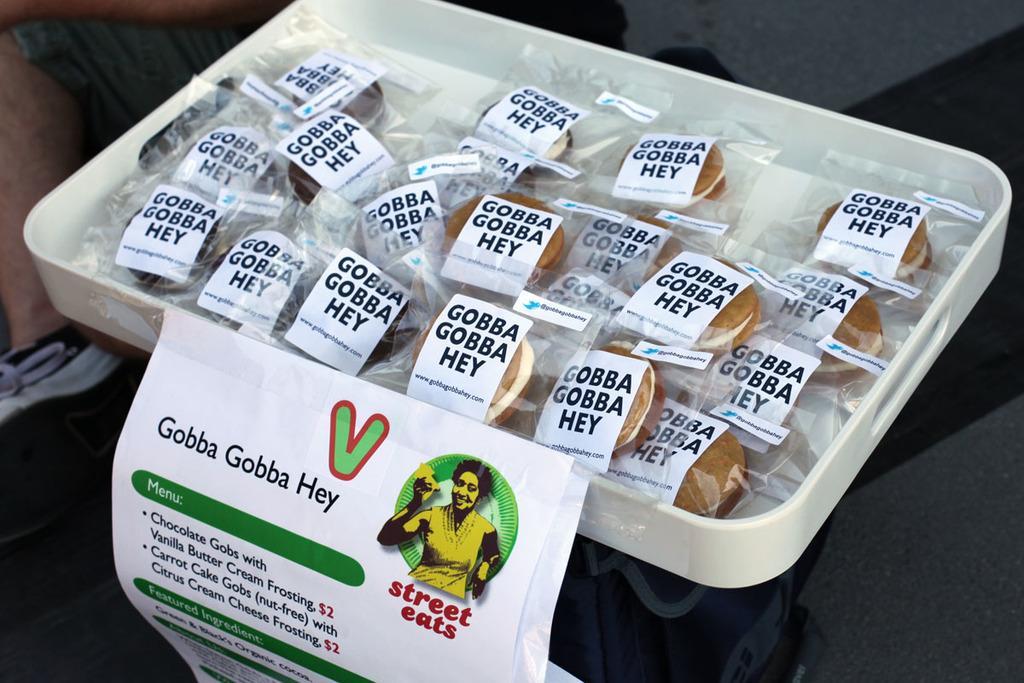Please provide a concise description of this image. These are the donuts in a white color tray. 